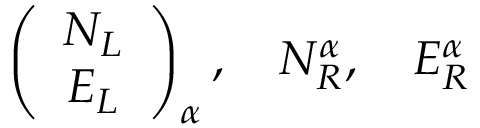<formula> <loc_0><loc_0><loc_500><loc_500>\left ( \begin{array} { c } { { N _ { L } } } \\ { { E _ { L } } } \end{array} \right ) _ { \alpha } , \quad N _ { R } ^ { \alpha } , \quad E _ { R } ^ { \alpha }</formula> 